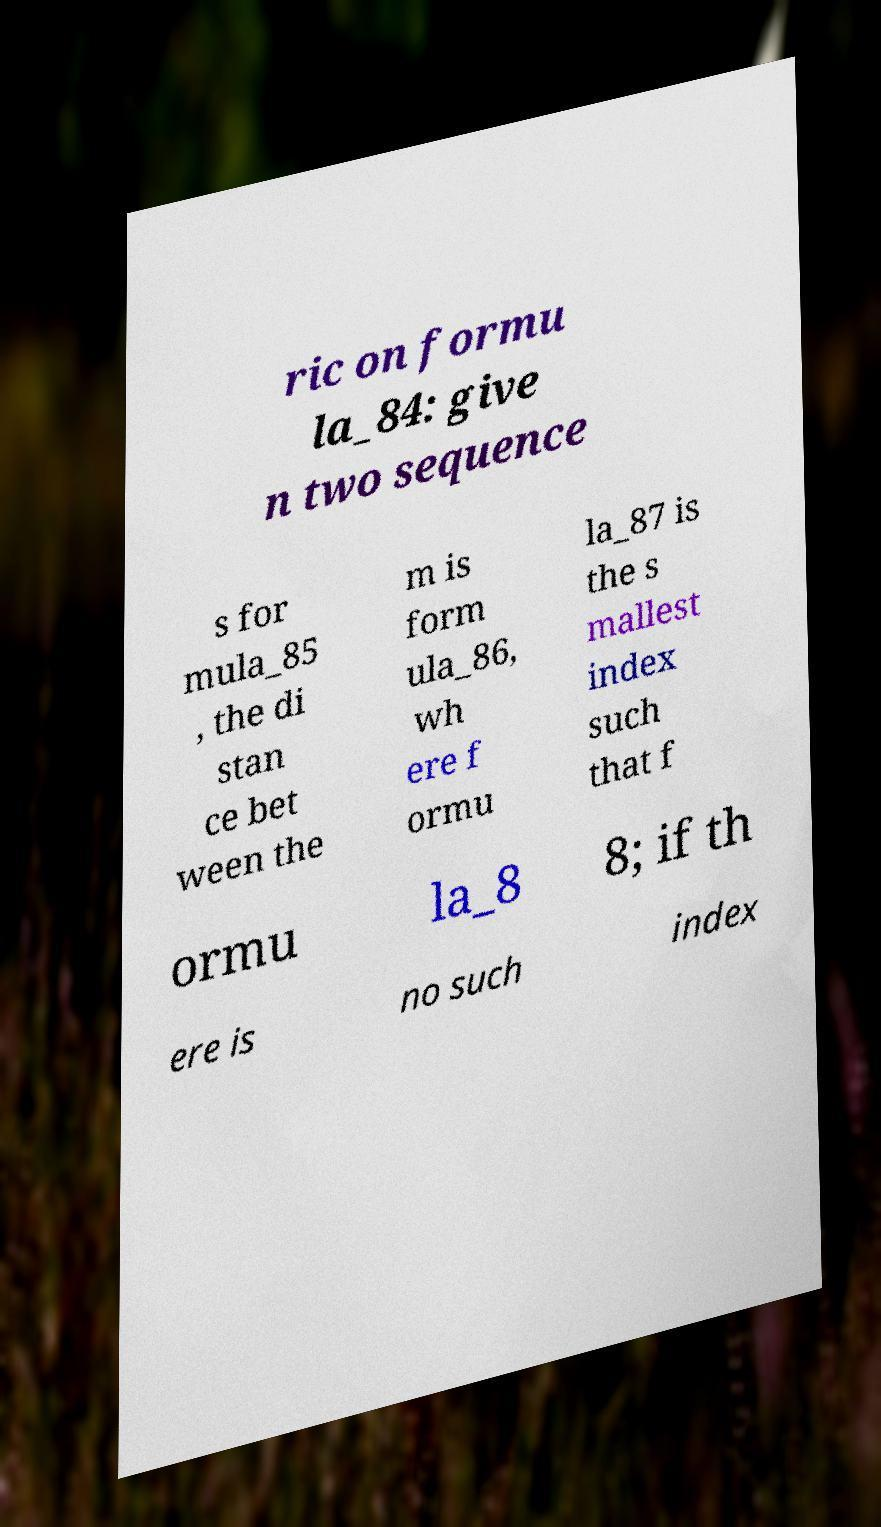Can you accurately transcribe the text from the provided image for me? ric on formu la_84: give n two sequence s for mula_85 , the di stan ce bet ween the m is form ula_86, wh ere f ormu la_87 is the s mallest index such that f ormu la_8 8; if th ere is no such index 